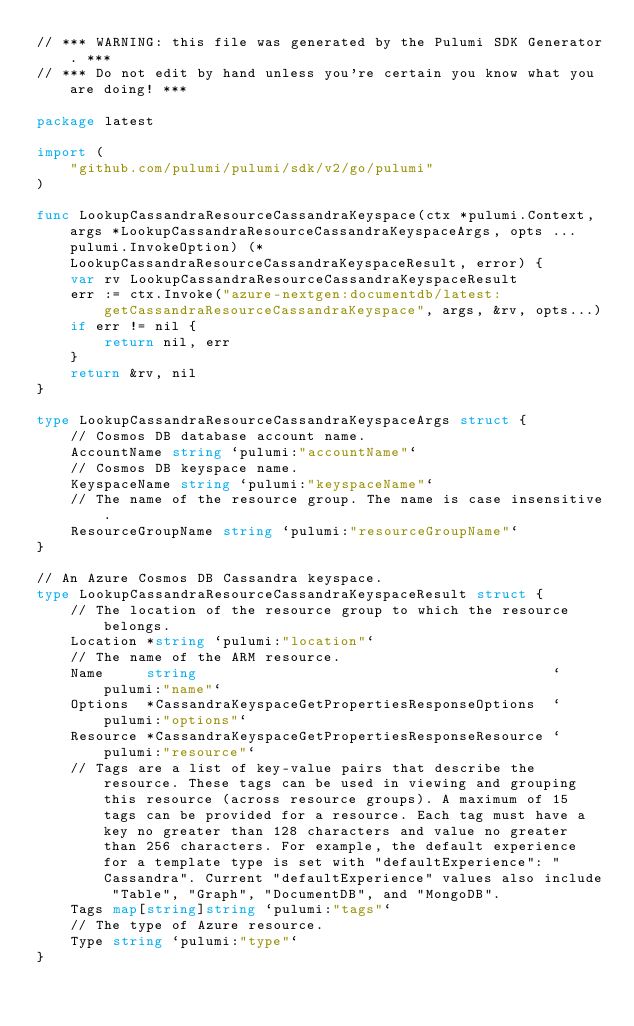Convert code to text. <code><loc_0><loc_0><loc_500><loc_500><_Go_>// *** WARNING: this file was generated by the Pulumi SDK Generator. ***
// *** Do not edit by hand unless you're certain you know what you are doing! ***

package latest

import (
	"github.com/pulumi/pulumi/sdk/v2/go/pulumi"
)

func LookupCassandraResourceCassandraKeyspace(ctx *pulumi.Context, args *LookupCassandraResourceCassandraKeyspaceArgs, opts ...pulumi.InvokeOption) (*LookupCassandraResourceCassandraKeyspaceResult, error) {
	var rv LookupCassandraResourceCassandraKeyspaceResult
	err := ctx.Invoke("azure-nextgen:documentdb/latest:getCassandraResourceCassandraKeyspace", args, &rv, opts...)
	if err != nil {
		return nil, err
	}
	return &rv, nil
}

type LookupCassandraResourceCassandraKeyspaceArgs struct {
	// Cosmos DB database account name.
	AccountName string `pulumi:"accountName"`
	// Cosmos DB keyspace name.
	KeyspaceName string `pulumi:"keyspaceName"`
	// The name of the resource group. The name is case insensitive.
	ResourceGroupName string `pulumi:"resourceGroupName"`
}

// An Azure Cosmos DB Cassandra keyspace.
type LookupCassandraResourceCassandraKeyspaceResult struct {
	// The location of the resource group to which the resource belongs.
	Location *string `pulumi:"location"`
	// The name of the ARM resource.
	Name     string                                          `pulumi:"name"`
	Options  *CassandraKeyspaceGetPropertiesResponseOptions  `pulumi:"options"`
	Resource *CassandraKeyspaceGetPropertiesResponseResource `pulumi:"resource"`
	// Tags are a list of key-value pairs that describe the resource. These tags can be used in viewing and grouping this resource (across resource groups). A maximum of 15 tags can be provided for a resource. Each tag must have a key no greater than 128 characters and value no greater than 256 characters. For example, the default experience for a template type is set with "defaultExperience": "Cassandra". Current "defaultExperience" values also include "Table", "Graph", "DocumentDB", and "MongoDB".
	Tags map[string]string `pulumi:"tags"`
	// The type of Azure resource.
	Type string `pulumi:"type"`
}
</code> 